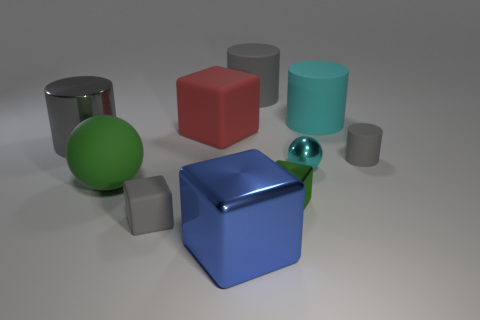Subtract all gray cylinders. How many were subtracted if there are1gray cylinders left? 2 Subtract all yellow spheres. How many gray cylinders are left? 3 Subtract 1 blocks. How many blocks are left? 3 Subtract all red blocks. How many blocks are left? 3 Subtract all purple cylinders. Subtract all brown cubes. How many cylinders are left? 4 Subtract all blocks. How many objects are left? 6 Add 1 yellow rubber balls. How many yellow rubber balls exist? 1 Subtract 0 purple cubes. How many objects are left? 10 Subtract all green shiny cubes. Subtract all blue shiny objects. How many objects are left? 8 Add 2 large blue shiny cubes. How many large blue shiny cubes are left? 3 